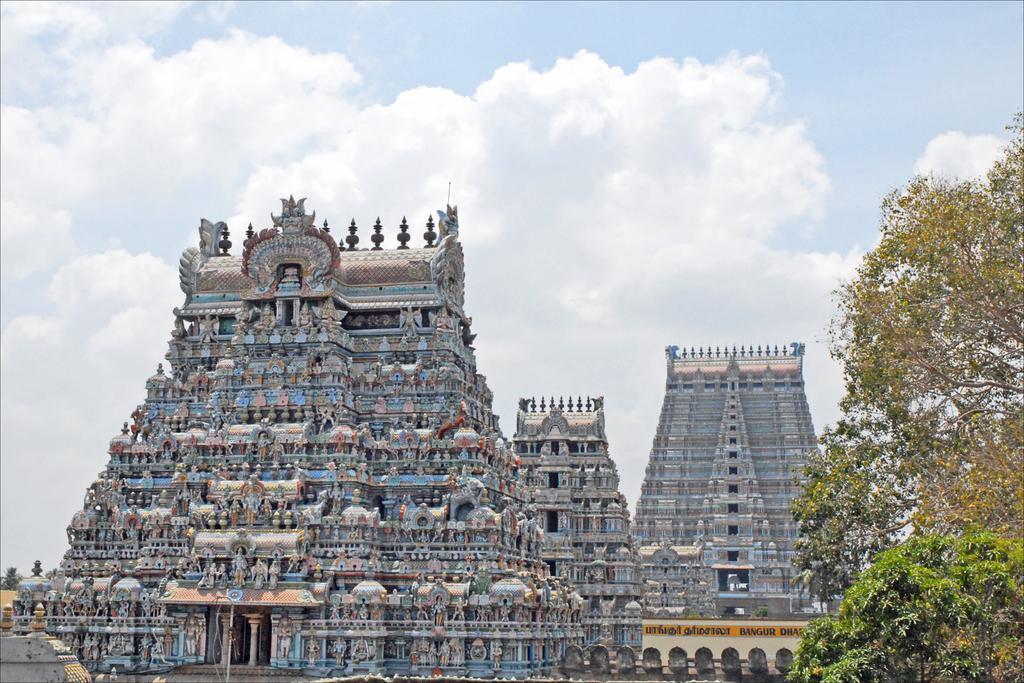Describe this image in one or two sentences. In this image in front there is a temple. On both right and left side of the image there are trees. In the background of the image there is sky. 